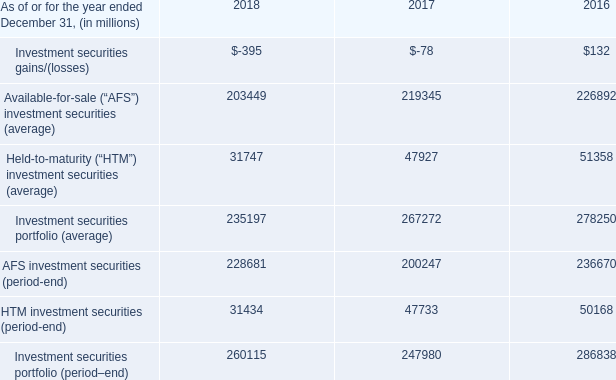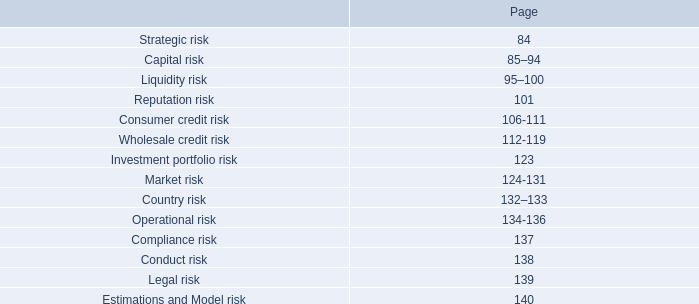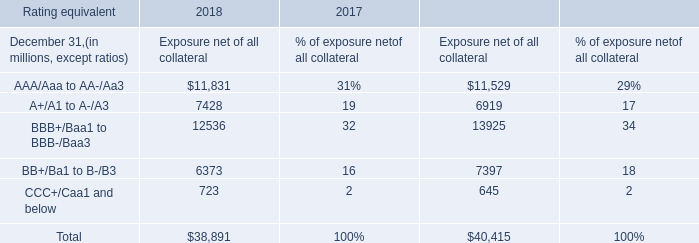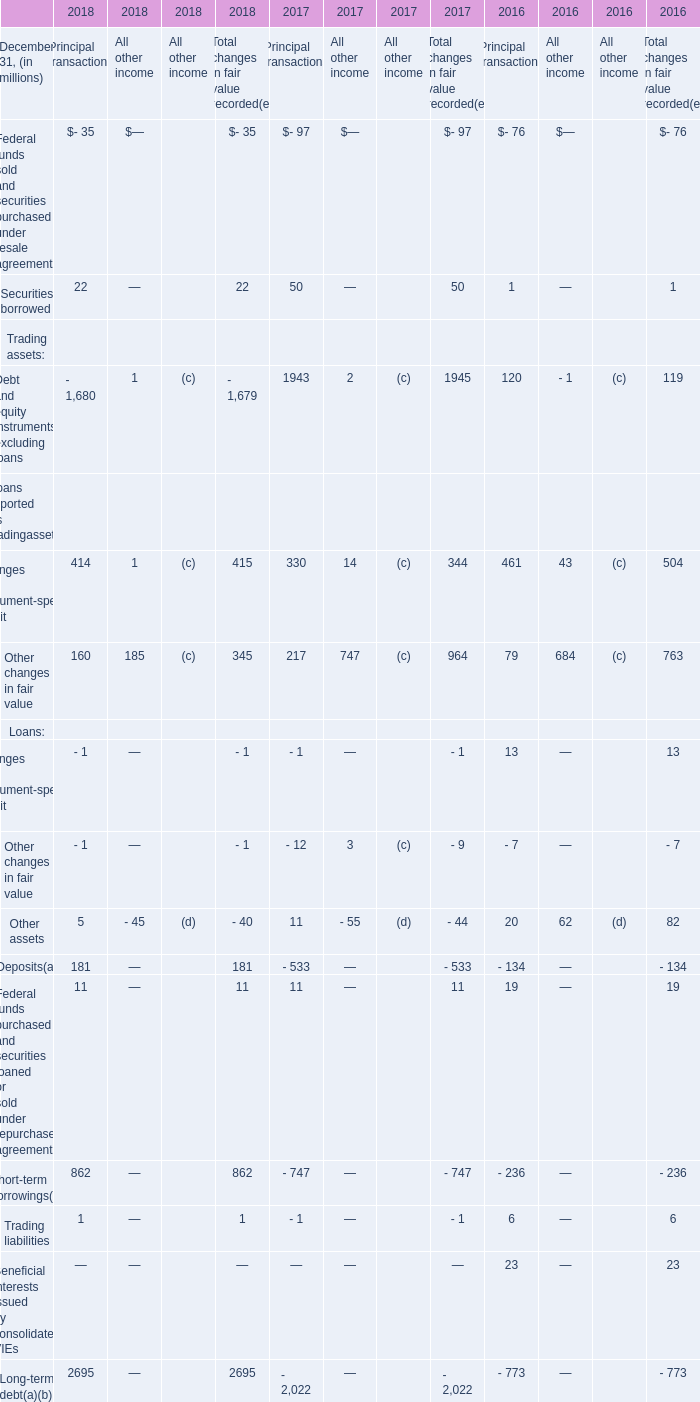What is the sum of the Long-term debt for Principal transactions as of December 31,2018? (in million) 
Answer: 2695. 